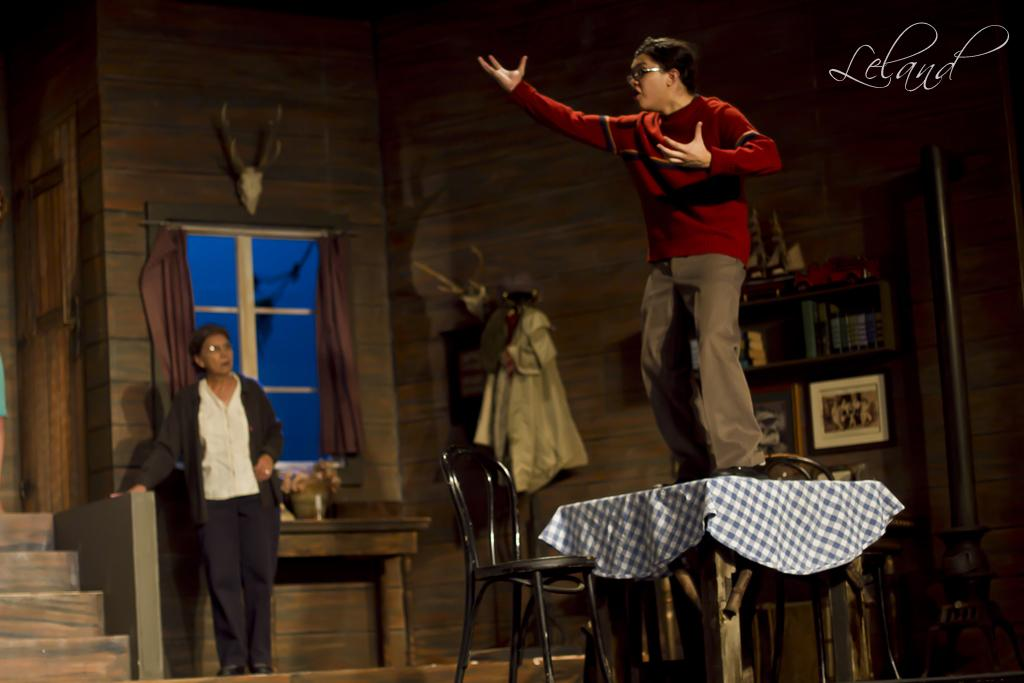What type of structure can be seen in the image? There is a wall in the image. What architectural feature is present in the wall? There is a window in the image. What type of furniture is visible in the image? There is a chair in the image. Are there any people present in the image? Yes, there are people in the image. What other piece of furniture can be seen in the image? There is a table in the image. What type of monkey can be seen sitting on the table in the image? There is no monkey present in the image; it only features a wall, window, chair, table, and people. What is the interest of the people in the image? The provided facts do not give any information about the interests of the people in the image. 